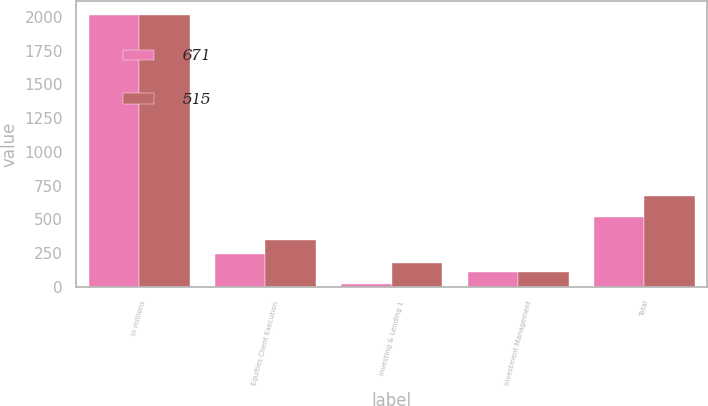Convert chart. <chart><loc_0><loc_0><loc_500><loc_500><stacked_bar_chart><ecel><fcel>in millions<fcel>Equities Client Execution<fcel>Investing & Lending 1<fcel>Investment Management<fcel>Total<nl><fcel>671<fcel>2014<fcel>246<fcel>18<fcel>113<fcel>515<nl><fcel>515<fcel>2013<fcel>348<fcel>180<fcel>108<fcel>671<nl></chart> 